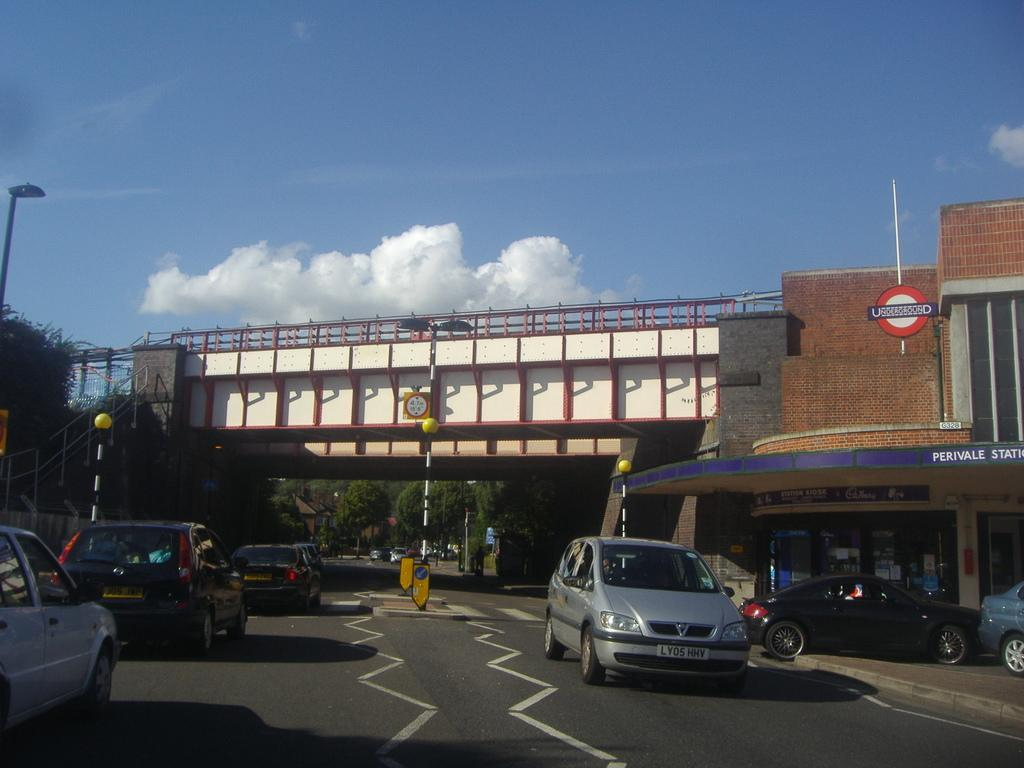What type of structures can be seen in the image? There are buildings in the image. What vehicles are present in the image? There are cars of different colors in the image. What type of lighting is present in the image? Street lamps are present in the image. What vertical structures can be seen in the image? Poles are visible in the image. What type of vegetation is present is in the image? Trees are in the image. What type of man-made structure is present in the image that allows for crossing over a body of water? There is a bridge in the image. What is visible at the top of the image? The sky is visible at the top of the image. What can be seen in the sky? There are clouds in the sky. How many spiders are crawling on the engine in the image? There is no engine present in the image, and therefore no spiders can be found on it. 